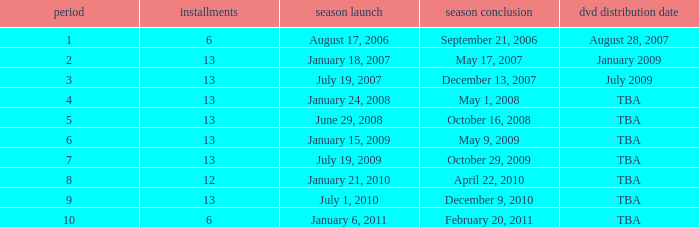Write the full table. {'header': ['period', 'installments', 'season launch', 'season conclusion', 'dvd distribution date'], 'rows': [['1', '6', 'August 17, 2006', 'September 21, 2006', 'August 28, 2007'], ['2', '13', 'January 18, 2007', 'May 17, 2007', 'January 2009'], ['3', '13', 'July 19, 2007', 'December 13, 2007', 'July 2009'], ['4', '13', 'January 24, 2008', 'May 1, 2008', 'TBA'], ['5', '13', 'June 29, 2008', 'October 16, 2008', 'TBA'], ['6', '13', 'January 15, 2009', 'May 9, 2009', 'TBA'], ['7', '13', 'July 19, 2009', 'October 29, 2009', 'TBA'], ['8', '12', 'January 21, 2010', 'April 22, 2010', 'TBA'], ['9', '13', 'July 1, 2010', 'December 9, 2010', 'TBA'], ['10', '6', 'January 6, 2011', 'February 20, 2011', 'TBA']]} Which season had fewer than 13 episodes and aired its season finale on February 20, 2011? 1.0. 